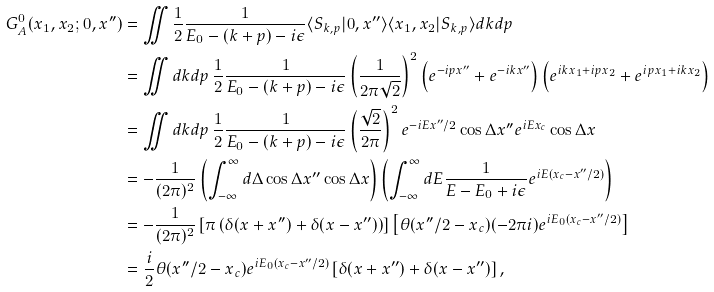<formula> <loc_0><loc_0><loc_500><loc_500>G ^ { 0 } _ { A } ( x _ { 1 } , x _ { 2 } ; 0 , x ^ { \prime \prime } ) & = \iint \frac { 1 } { 2 } \frac { 1 } { E _ { 0 } - ( k + p ) - i \epsilon } \langle S _ { k , p } | 0 , x ^ { \prime \prime } \rangle \langle x _ { 1 } , x _ { 2 } | S _ { k , p } \rangle d k d p \\ & = \iint d k d p \, \frac { 1 } { 2 } \frac { 1 } { E _ { 0 } - ( k + p ) - i \epsilon } \left ( \frac { 1 } { 2 \pi \sqrt { 2 } } \right ) ^ { 2 } \left ( e ^ { - i p x ^ { \prime \prime } } + e ^ { - i k x ^ { \prime \prime } } \right ) \left ( e ^ { i k x _ { 1 } + i p x _ { 2 } } + e ^ { i p x _ { 1 } + i k x _ { 2 } } \right ) \\ & = \iint d k d p \, \frac { 1 } { 2 } \frac { 1 } { E _ { 0 } - ( k + p ) - i \epsilon } \left ( \frac { \sqrt { 2 } } { 2 \pi } \right ) ^ { 2 } e ^ { - i E x ^ { \prime \prime } / 2 } \cos \Delta x ^ { \prime \prime } e ^ { i E x _ { c } } \cos \Delta x \\ & = - \frac { 1 } { ( 2 \pi ) ^ { 2 } } \left ( \int _ { - \infty } ^ { \infty } d \Delta \cos \Delta x ^ { \prime \prime } \cos \Delta x \right ) \left ( \int _ { - \infty } ^ { \infty } d E \frac { 1 } { E - E _ { 0 } + i \epsilon } e ^ { i E ( x _ { c } - x ^ { \prime \prime } / 2 ) } \right ) \\ & = - \frac { 1 } { ( 2 \pi ) ^ { 2 } } \left [ \pi \left ( \delta ( x + x ^ { \prime \prime } ) + \delta ( x - x ^ { \prime \prime } ) \right ) \right ] \left [ \theta ( x ^ { \prime \prime } / 2 - x _ { c } ) ( - 2 \pi i ) e ^ { i E _ { 0 } ( x _ { c } - x ^ { \prime \prime } / 2 ) } \right ] \\ & = \frac { i } { 2 } \theta ( x ^ { \prime \prime } / 2 - x _ { c } ) e ^ { i E _ { 0 } ( x _ { c } - x ^ { \prime \prime } / 2 ) } \left [ \delta ( x + x ^ { \prime \prime } ) + \delta ( x - x ^ { \prime \prime } ) \right ] ,</formula> 